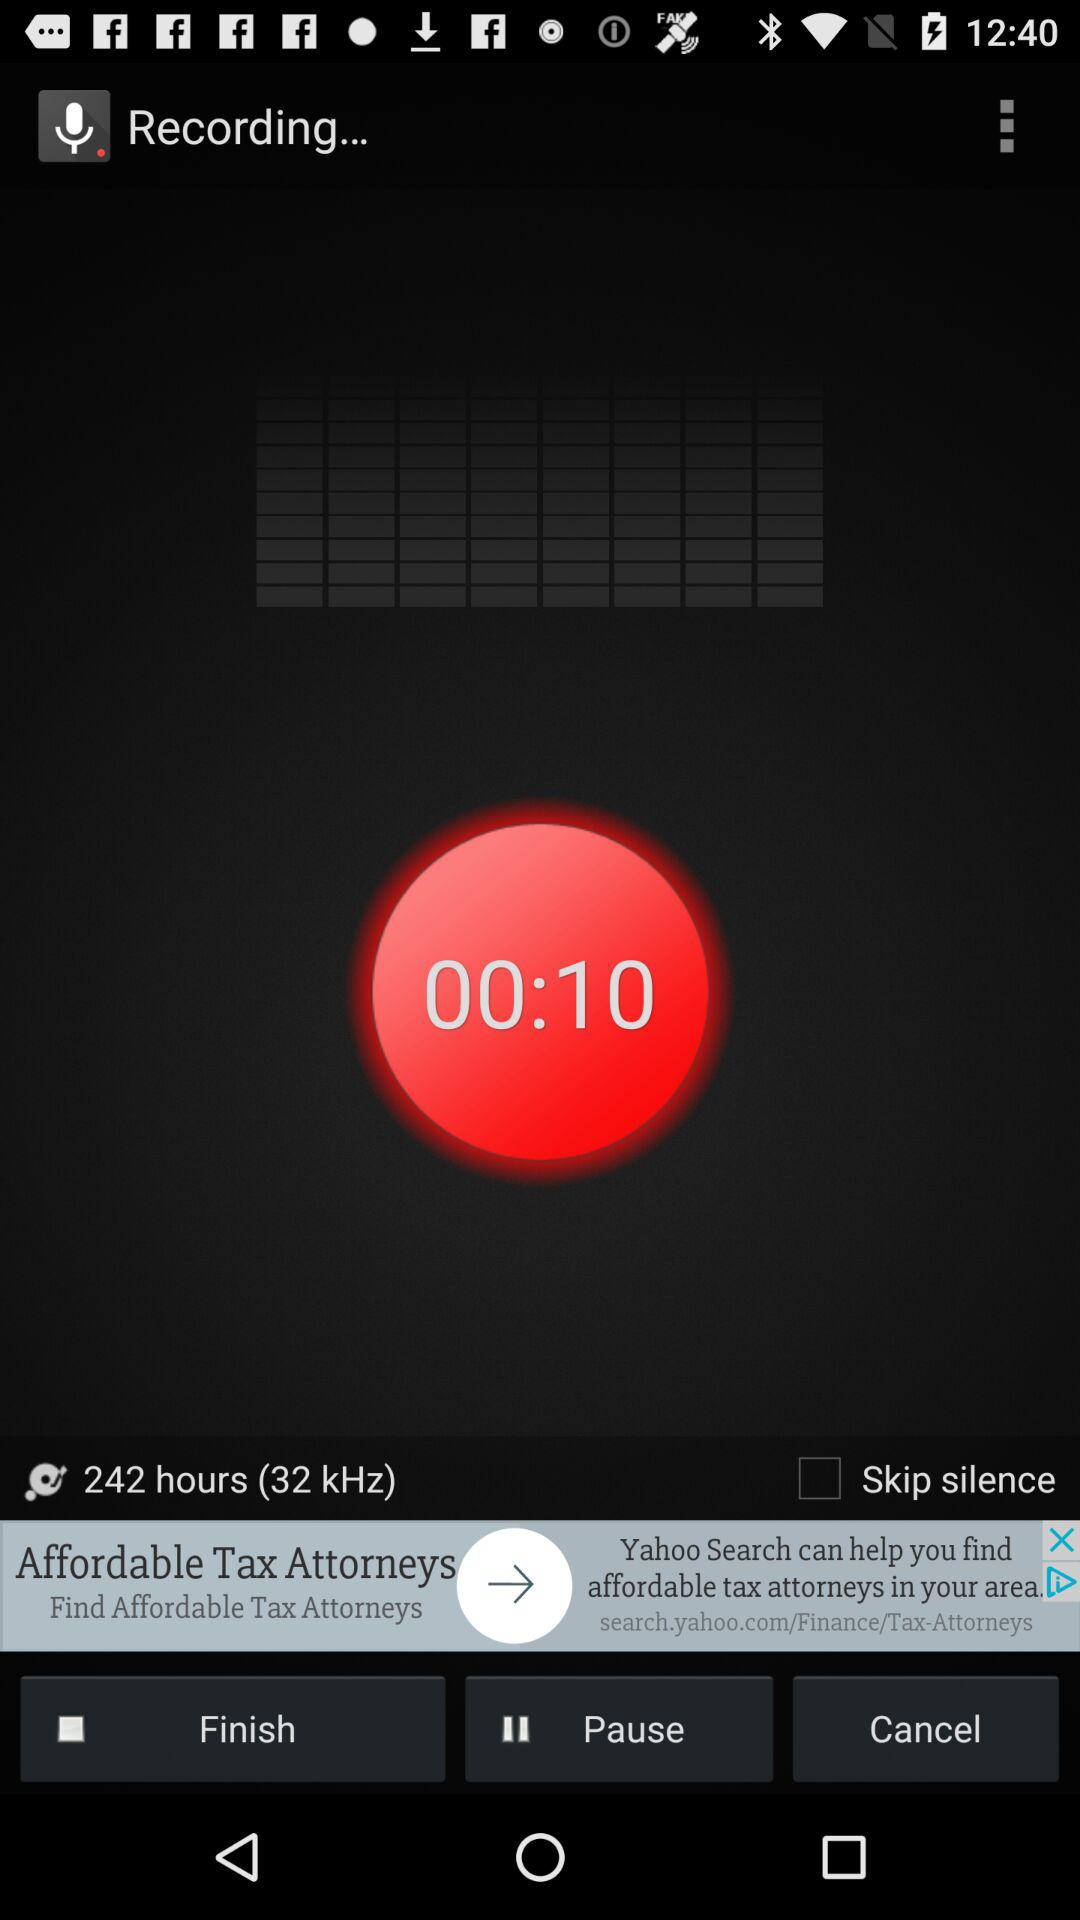What is the frequency? The frequency is 32 kHz. 